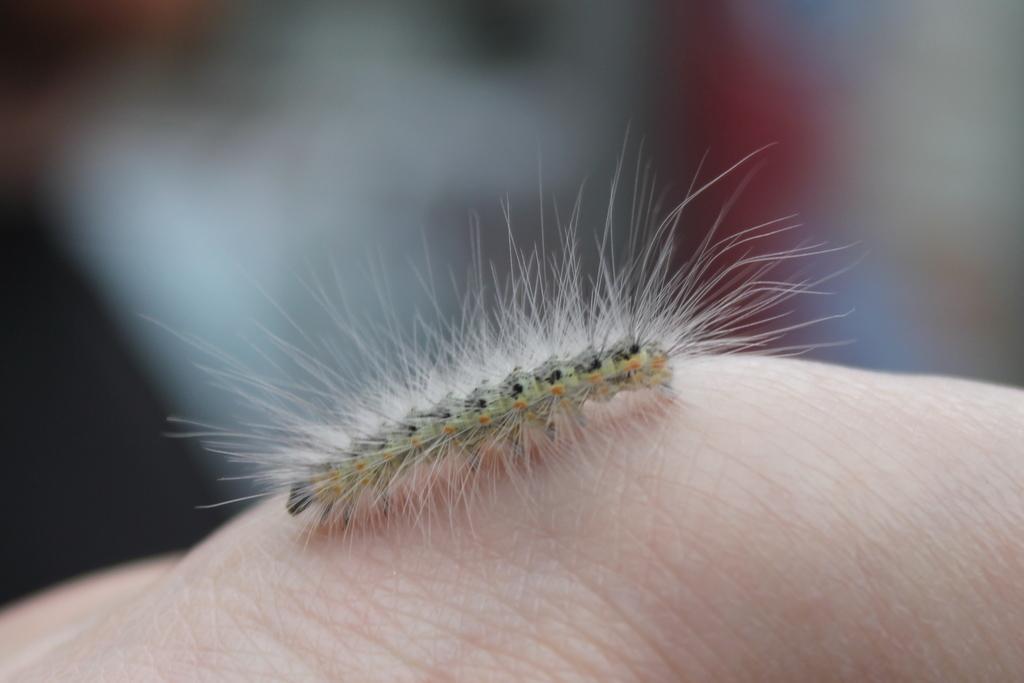Can you describe this image briefly? This is a zoomed in picture. In the foreground there is an insect on the body of a person. The background of the image is blurry. 